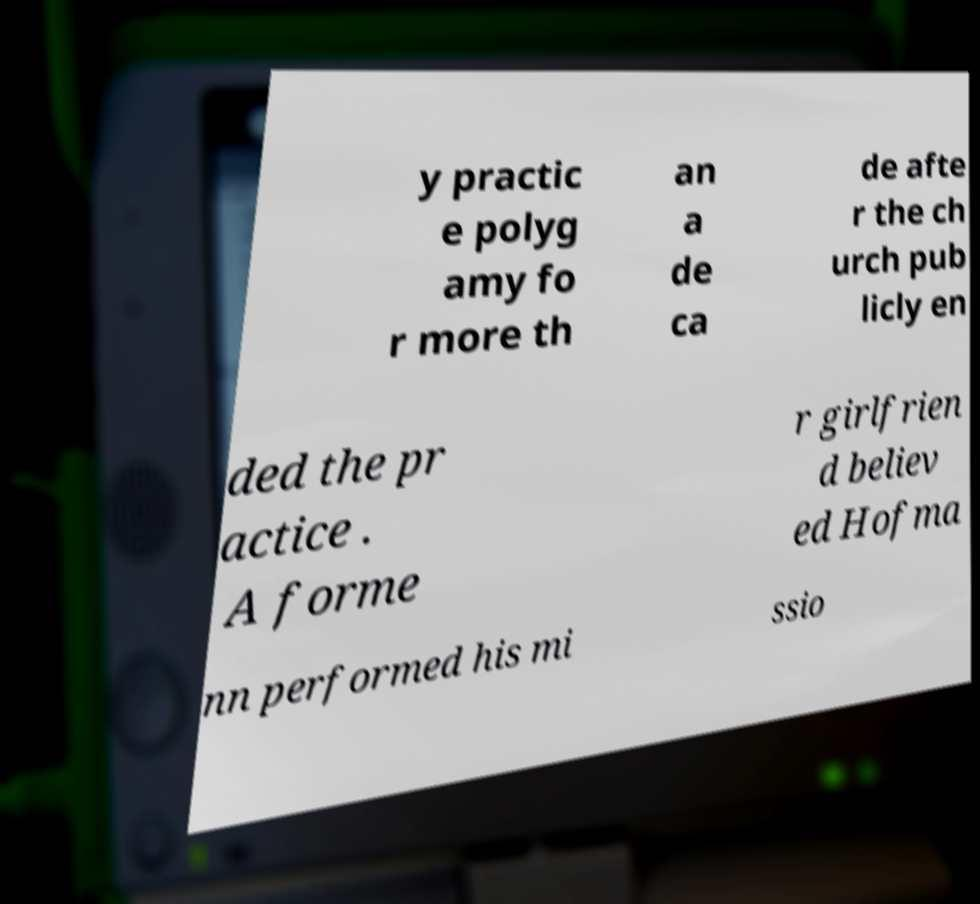For documentation purposes, I need the text within this image transcribed. Could you provide that? y practic e polyg amy fo r more th an a de ca de afte r the ch urch pub licly en ded the pr actice . A forme r girlfrien d believ ed Hofma nn performed his mi ssio 